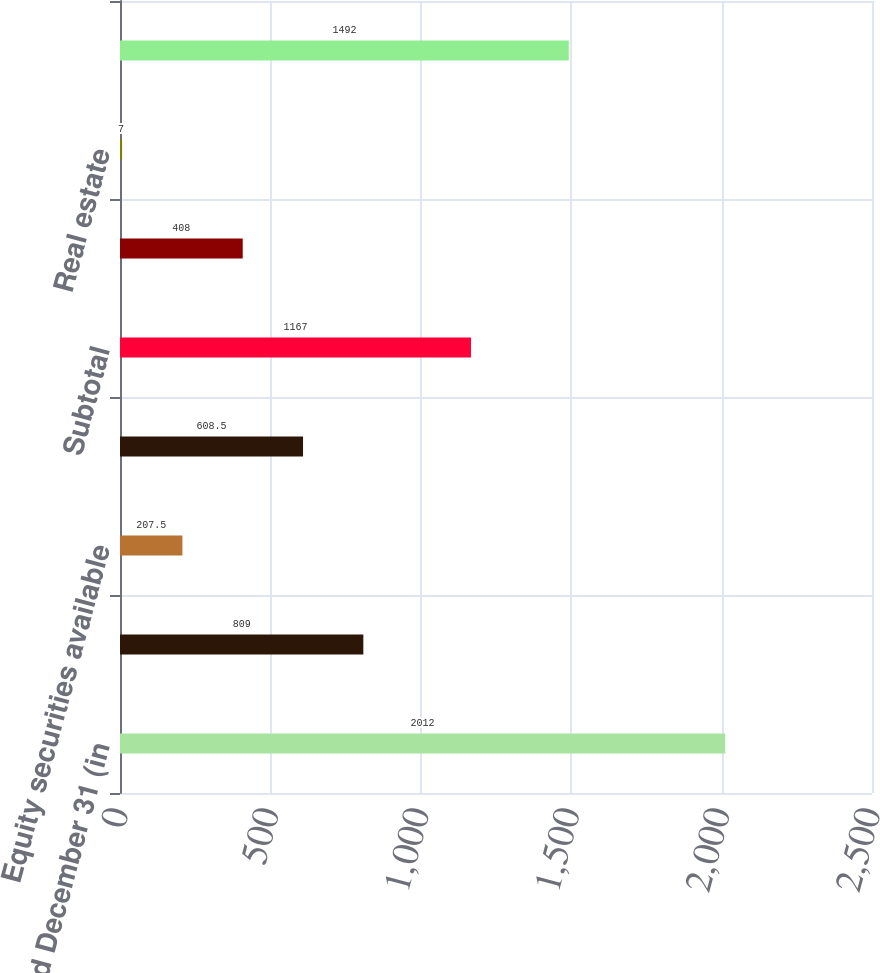Convert chart. <chart><loc_0><loc_0><loc_500><loc_500><bar_chart><fcel>Years Ended December 31 (in<fcel>Fixed maturity securities<fcel>Equity securities available<fcel>Private equity funds and hedge<fcel>Subtotal<fcel>Investments in life<fcel>Real estate<fcel>Total<nl><fcel>2012<fcel>809<fcel>207.5<fcel>608.5<fcel>1167<fcel>408<fcel>7<fcel>1492<nl></chart> 